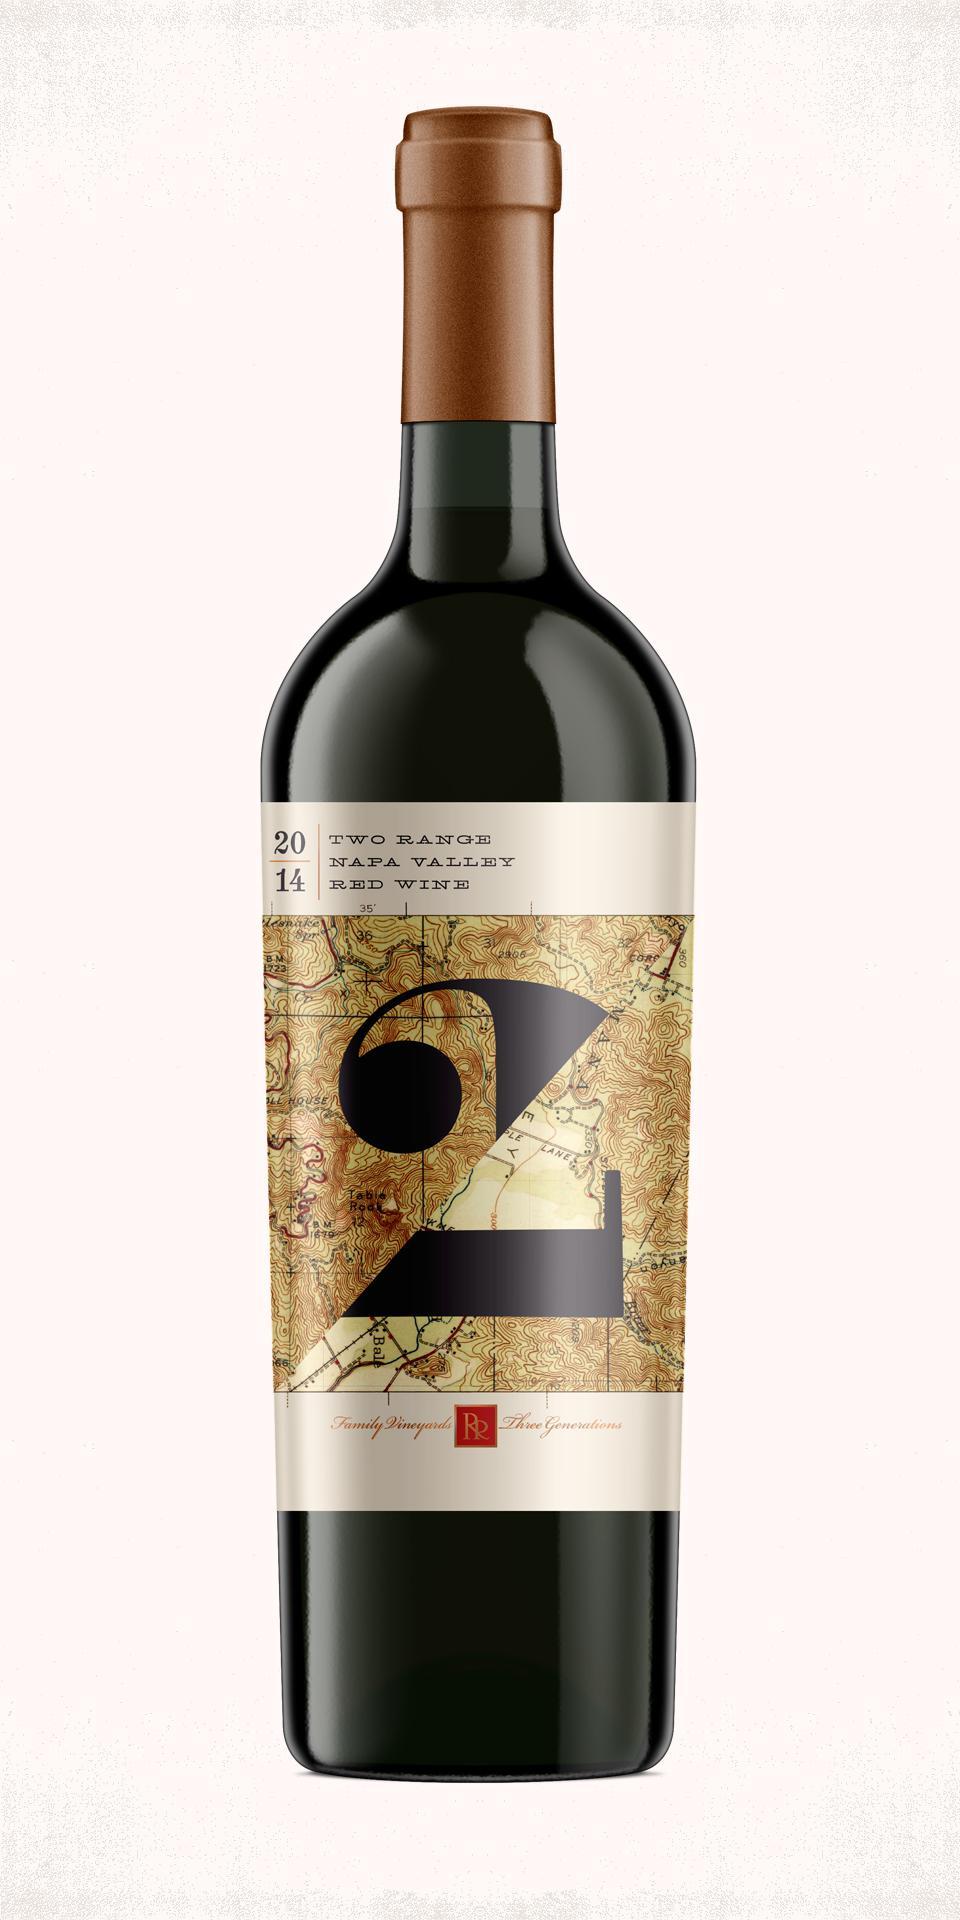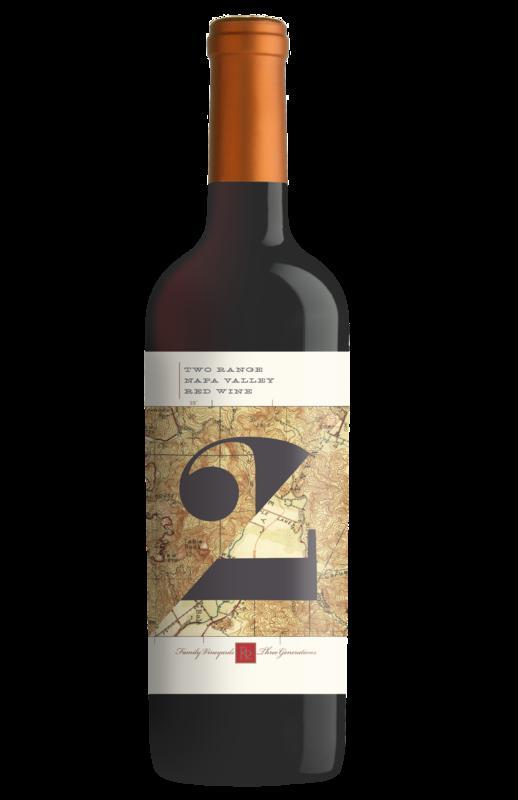The first image is the image on the left, the second image is the image on the right. Considering the images on both sides, is "One image shows a bottle of wine with a black background." valid? Answer yes or no. Yes. 